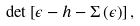Convert formula to latex. <formula><loc_0><loc_0><loc_500><loc_500>\det \left [ \epsilon - h - \Sigma \left ( \epsilon \right ) \right ] ,</formula> 